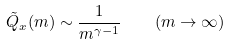Convert formula to latex. <formula><loc_0><loc_0><loc_500><loc_500>\tilde { Q } _ { x } ( m ) \sim \frac { 1 } { m ^ { \gamma - 1 } } \quad ( m \to \infty )</formula> 